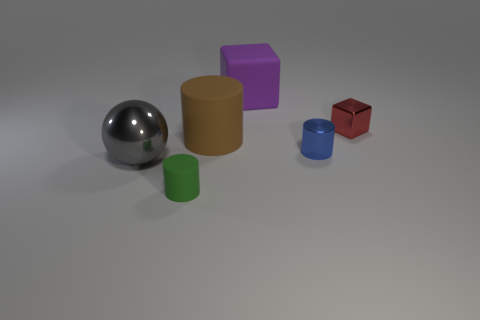What material is the blue object that is the same size as the red cube?
Offer a terse response. Metal. How many blue things are either metal cylinders or big cylinders?
Your answer should be compact. 1. What color is the big thing that is the same material as the brown cylinder?
Your answer should be very brief. Purple. Is there any other thing that is the same size as the green thing?
Offer a terse response. Yes. What number of small objects are either gray metallic objects or cyan shiny blocks?
Keep it short and to the point. 0. Are there fewer big blue balls than small red cubes?
Your answer should be very brief. Yes. There is another small object that is the same shape as the small blue thing; what is its color?
Your answer should be compact. Green. Are there any other things that are the same shape as the red metallic object?
Ensure brevity in your answer.  Yes. Are there more tiny blue balls than small red objects?
Your response must be concise. No. What number of other things are the same material as the green object?
Give a very brief answer. 2. 